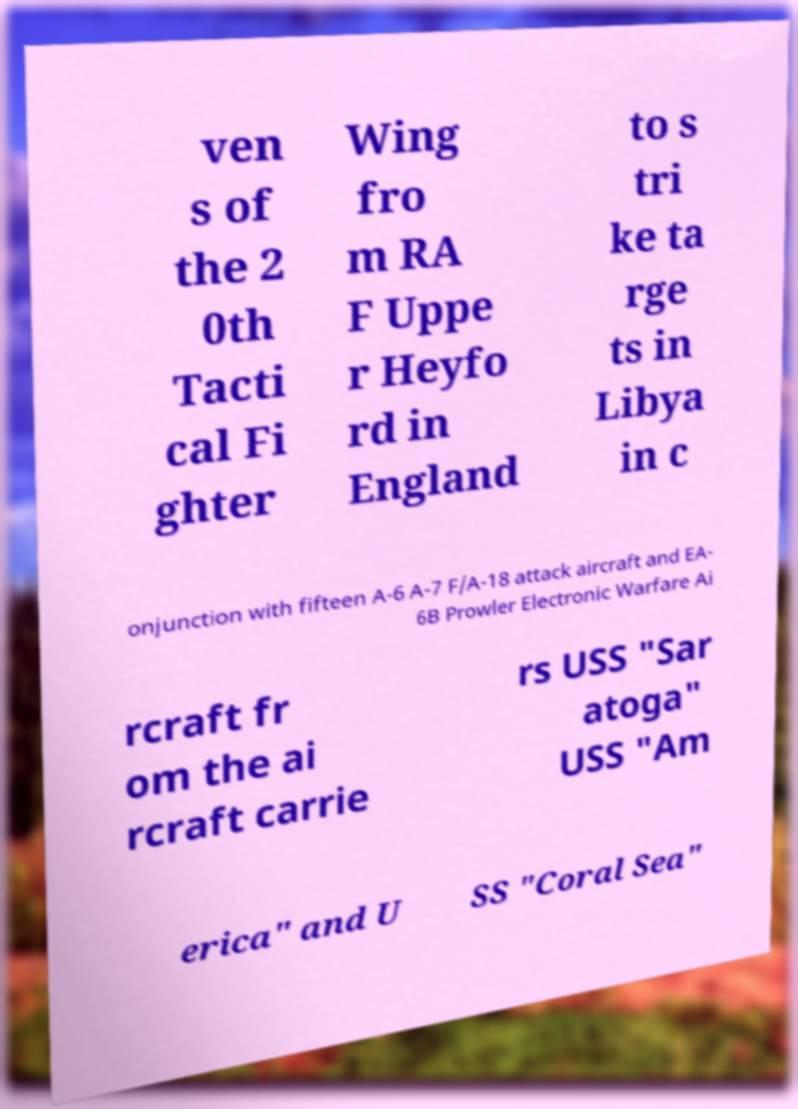Please read and relay the text visible in this image. What does it say? ven s of the 2 0th Tacti cal Fi ghter Wing fro m RA F Uppe r Heyfo rd in England to s tri ke ta rge ts in Libya in c onjunction with fifteen A-6 A-7 F/A-18 attack aircraft and EA- 6B Prowler Electronic Warfare Ai rcraft fr om the ai rcraft carrie rs USS "Sar atoga" USS "Am erica" and U SS "Coral Sea" 